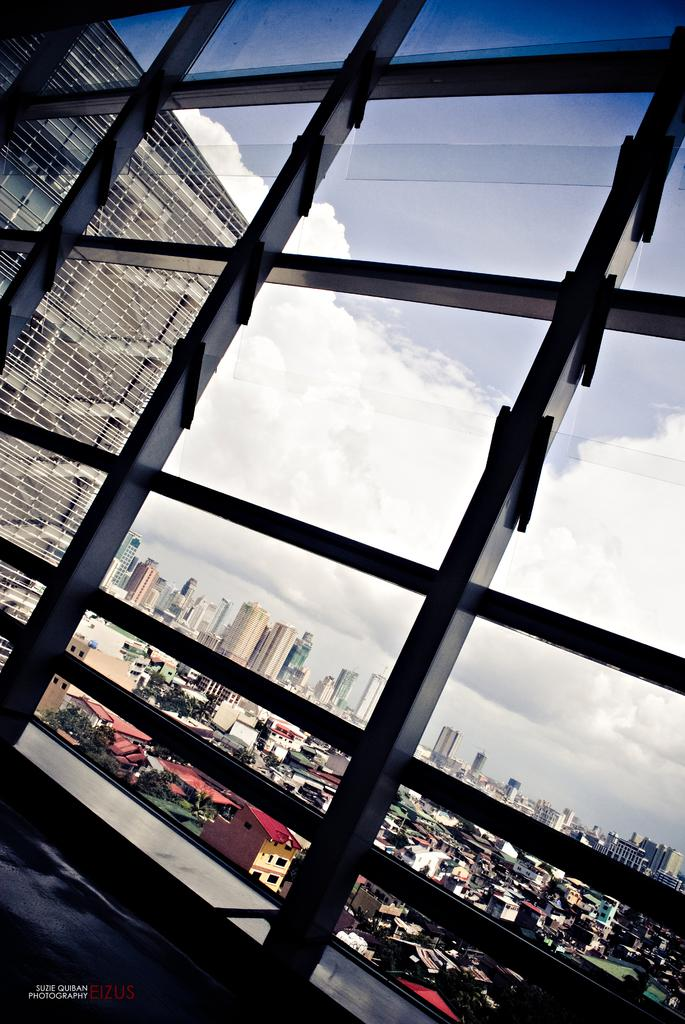What is the main subject of the image? The main subject of the image is the windows of a building. What can be seen in the background of the image? There are buildings and houses in the background of the image. What is visible above the buildings and houses? The sky is visible in the image. What is the condition of the sky in the image? Clouds are present in the sky. What type of flower can be seen growing on the windowsill in the image? There is no flower visible on the windowsill in the image. 